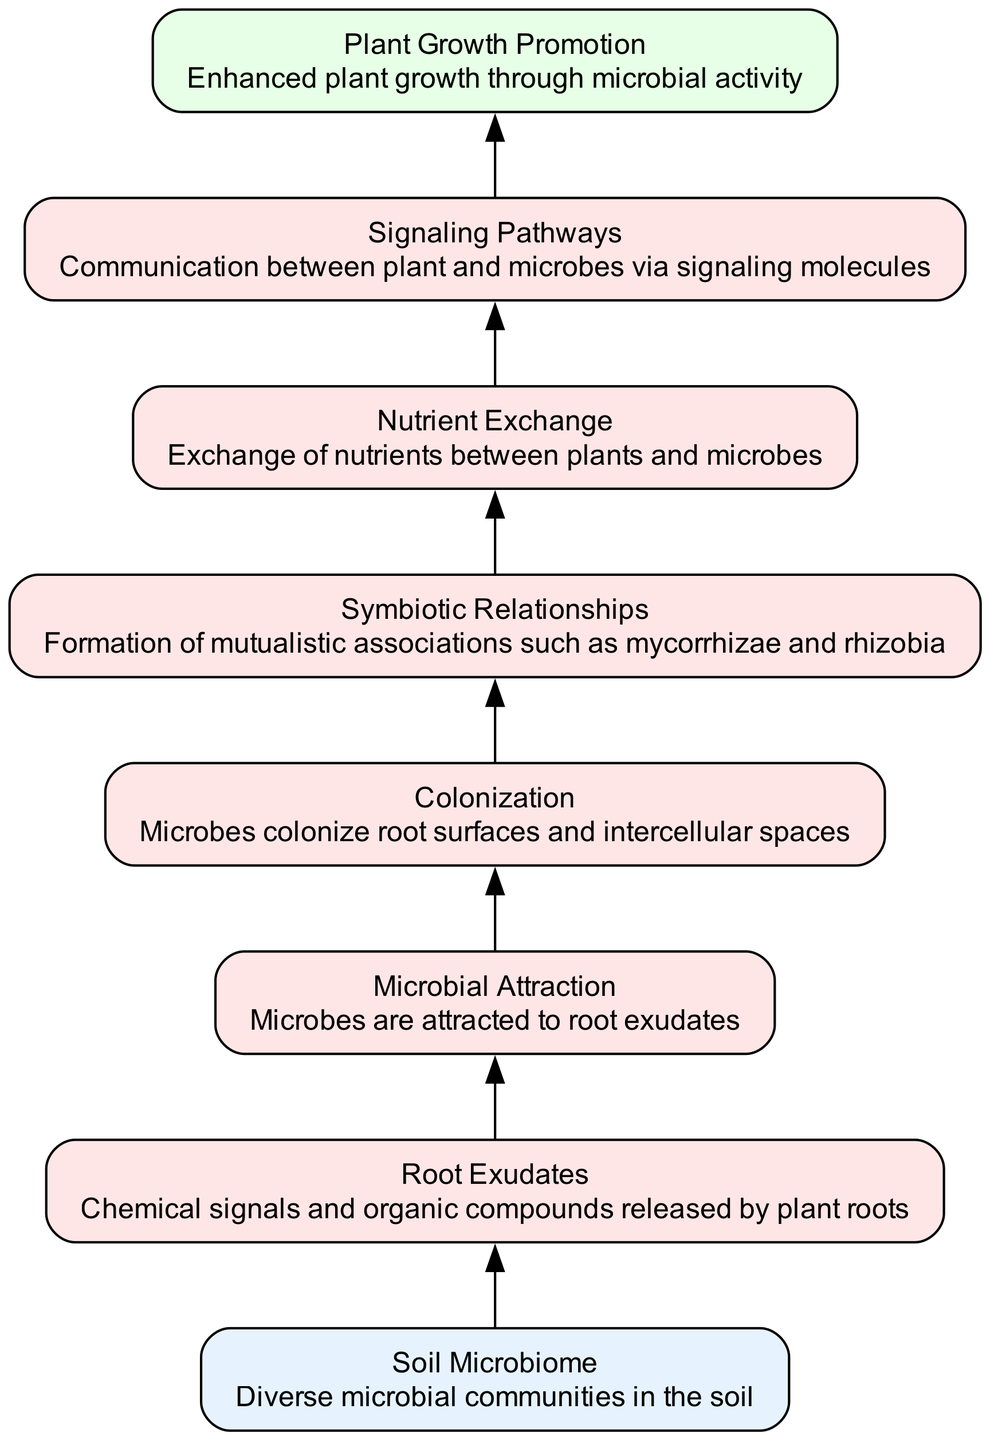What is the input of this diagram? The input of the diagram is the "Soil Microbiome," which consists of diverse microbial communities in the soil, denoted as the first node at the bottom of the flow chart.
Answer: Soil Microbiome What is the output of this diagram? The output of the diagram is "Plant Growth Promotion," which is the final outcome of the processes described in the flow chart, represented at the top node.
Answer: Plant Growth Promotion How many processes are involved in this diagram? The diagram includes six processes: Root Exudates, Microbial Attraction, Colonization, Symbiotic Relationships, Nutrient Exchange, and Signaling Pathways. Counting these processes yields a total of six.
Answer: Six Which node follows the "Colonization" node? The node that follows "Colonization" in the flow chart is "Symbiotic Relationships," indicating the next step in the plant-microbe interaction dynamics after colonization occurs.
Answer: Symbiotic Relationships What is the relationship between "Microbial Attraction" and "Root Exudates"? The relationship is that "Microbial Attraction" occurs as a result of the "Root Exudates," meaning that microbes are attracted to the chemical signals and organic compounds released by plant roots.
Answer: Attraction How do "Nutrient Exchange" and "Plant Growth Promotion" relate to each other? "Nutrient Exchange" directly leads to "Plant Growth Promotion," showing that the exchange of nutrients between plants and microbes contributes to enhanced plant growth through microbial activity.
Answer: Directly related Which process occurs after "Signaling Pathways"? The process that occurs after "Signaling Pathways" is "Plant Growth Promotion," indicating that after the signaling exchange between plants and microbes, the result is an enhancement in plant growth.
Answer: Plant Growth Promotion What type of relationship does node "Symbiotic Relationships" refer to? The "Symbiotic Relationships" node refers to mutualistic associations, such as mycorrhizae and rhizobia, representing a beneficial interaction that enhances both partners involved.
Answer: Mutualistic associations 